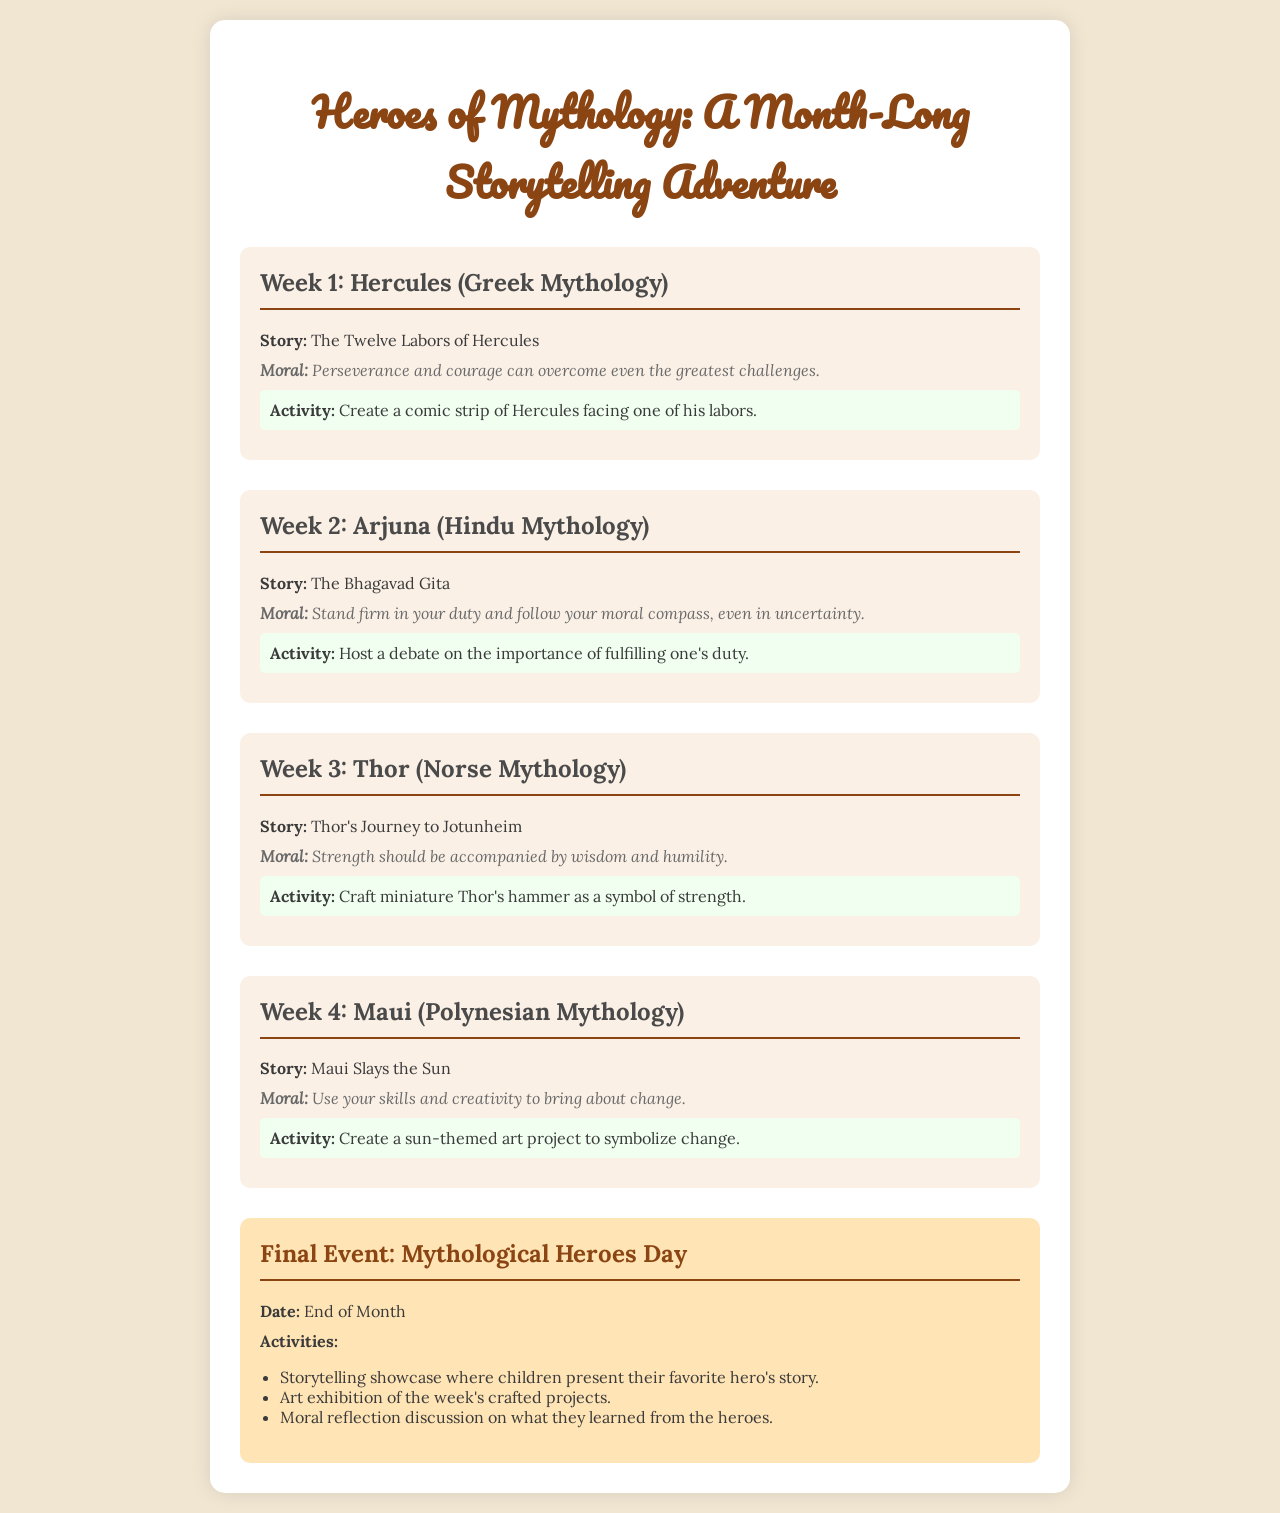What is the title of the event? The title of the event is found in the header of the document.
Answer: Heroes of Mythology: A Month-Long Storytelling Adventure Who is the hero from Greek mythology featured in Week 1? The hero featured in Week 1 is listed under the first week's heading.
Answer: Hercules What story is associated with Arjuna? The associated story for Arjuna is mentioned in the second week's description.
Answer: The Bhagavad Gita What moral lesson does Thor's story convey? The moral lesson is provided in the description of the third week.
Answer: Strength should be accompanied by wisdom and humility What activity is suggested for the last week? The suggested activity for the last week is found in the description of Maui's story.
Answer: Create a sun-themed art project to symbolize change How many weeks are dedicated to storytelling adventures? The number of weeks can be counted from the sections in the document.
Answer: 4 What is the date of the final event? The date for the final event is specified towards the end of the document.
Answer: End of Month What type of cultural heroes are primarily featured? The type of heroes featured can be inferred from the title and descriptions throughout the document.
Answer: Mythological 